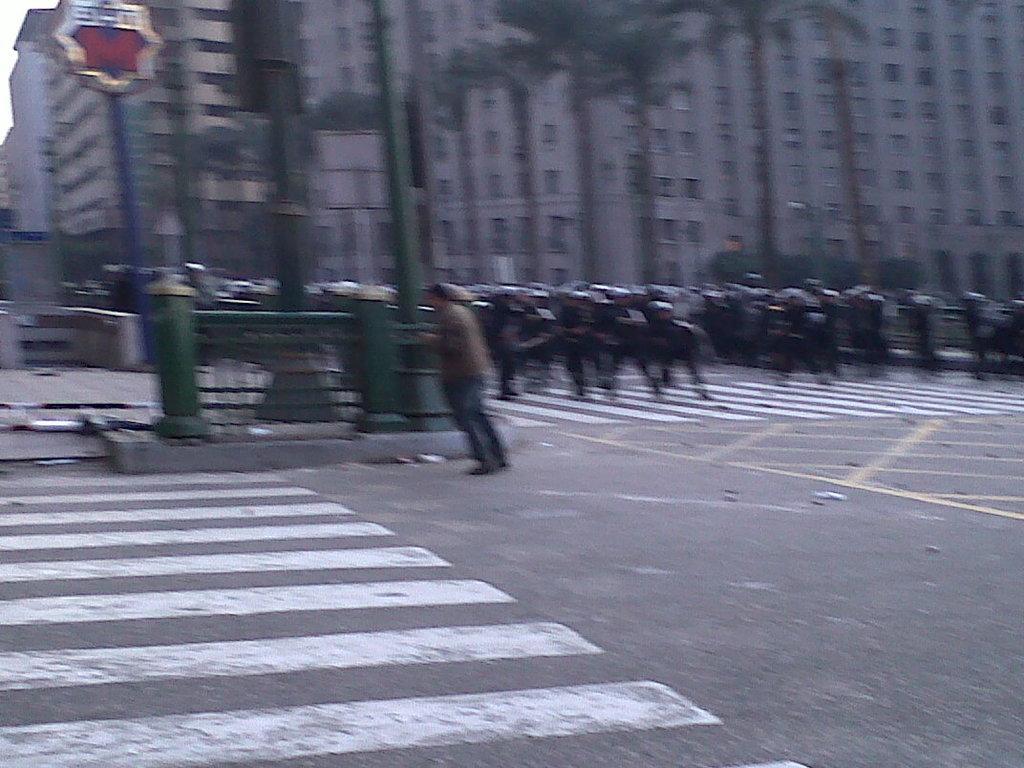Please provide a concise description of this image. There are few persons on the road and there are trees and buildings in the background. 